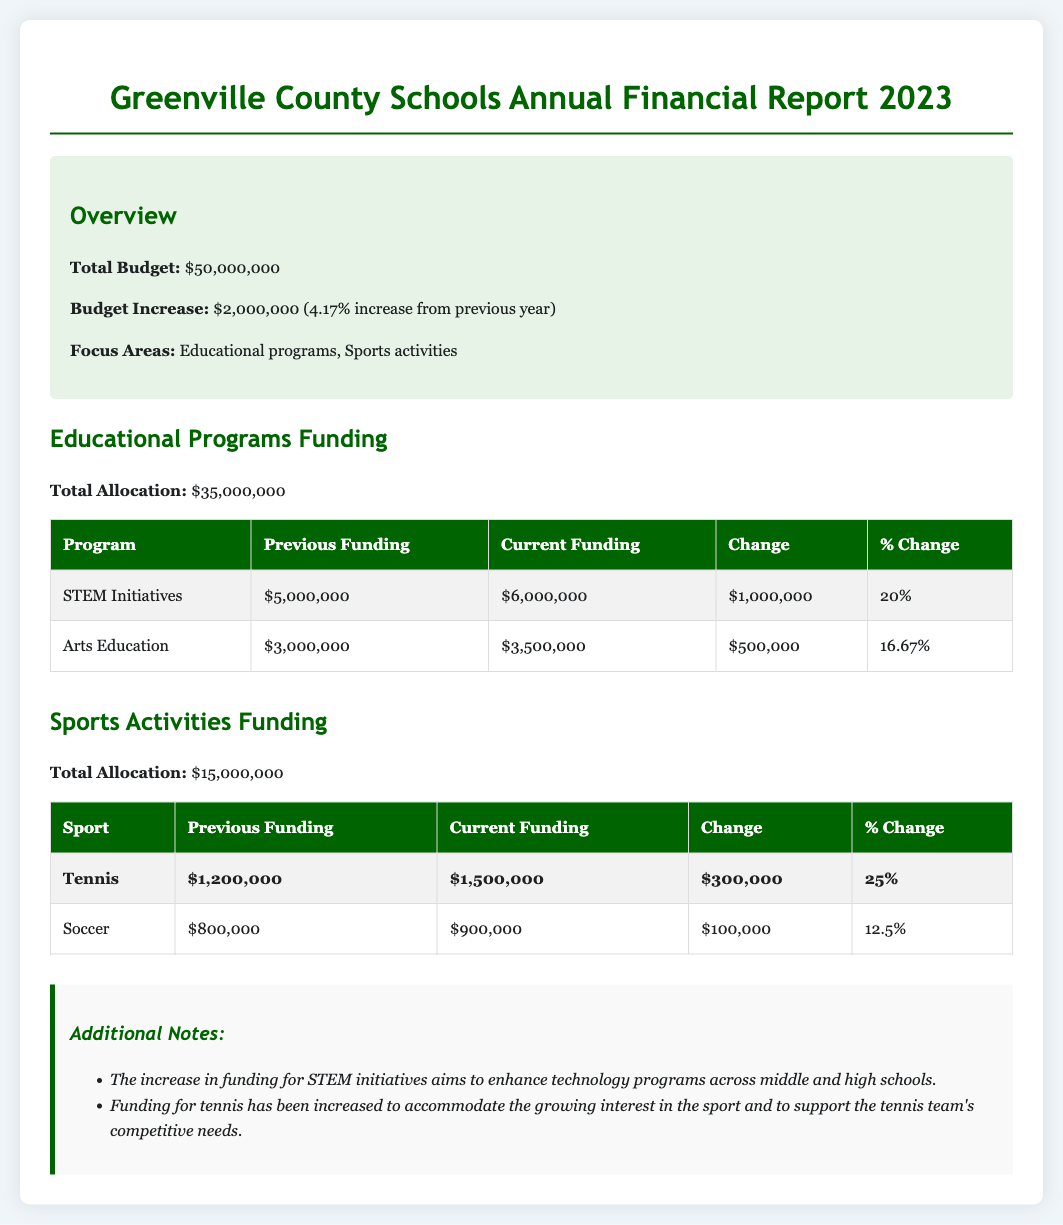What is the total budget for Greenville County Schools in 2023? The total budget is stated in the overview section of the document.
Answer: $50,000,000 What is the budget increase from the previous year? The budget increase is mentioned in the overview section of the document.
Answer: $2,000,000 What percentage increase does the budget represent? The percentage increase is also included in the overview section of the document.
Answer: 4.17% How much funding is allocated for STEM initiatives? The funding allocation for STEM initiatives is detailed in the educational programs funding section.
Answer: $6,000,000 By how much was the funding for tennis increased? The change in funding for tennis is shown in the sports activities funding table.
Answer: $300,000 What was the previous funding for soccer? The previous funding for soccer is indicated in the sports activities funding table.
Answer: $800,000 What focus areas are highlighted in the budget allocation? The focus areas of the budget are listed in the overview section of the document.
Answer: Educational programs, Sports activities Which educational program received a 20% funding increase? The percentage change for each program is provided in the educational programs funding table.
Answer: STEM Initiatives How much is the total funding allocation for sports activities? The total funding allocation for sports activities is presented in the sports activities funding section.
Answer: $15,000,000 What is the current funding amount for the Arts Education program? The current funding amount is found in the educational programs funding section.
Answer: $3,500,000 